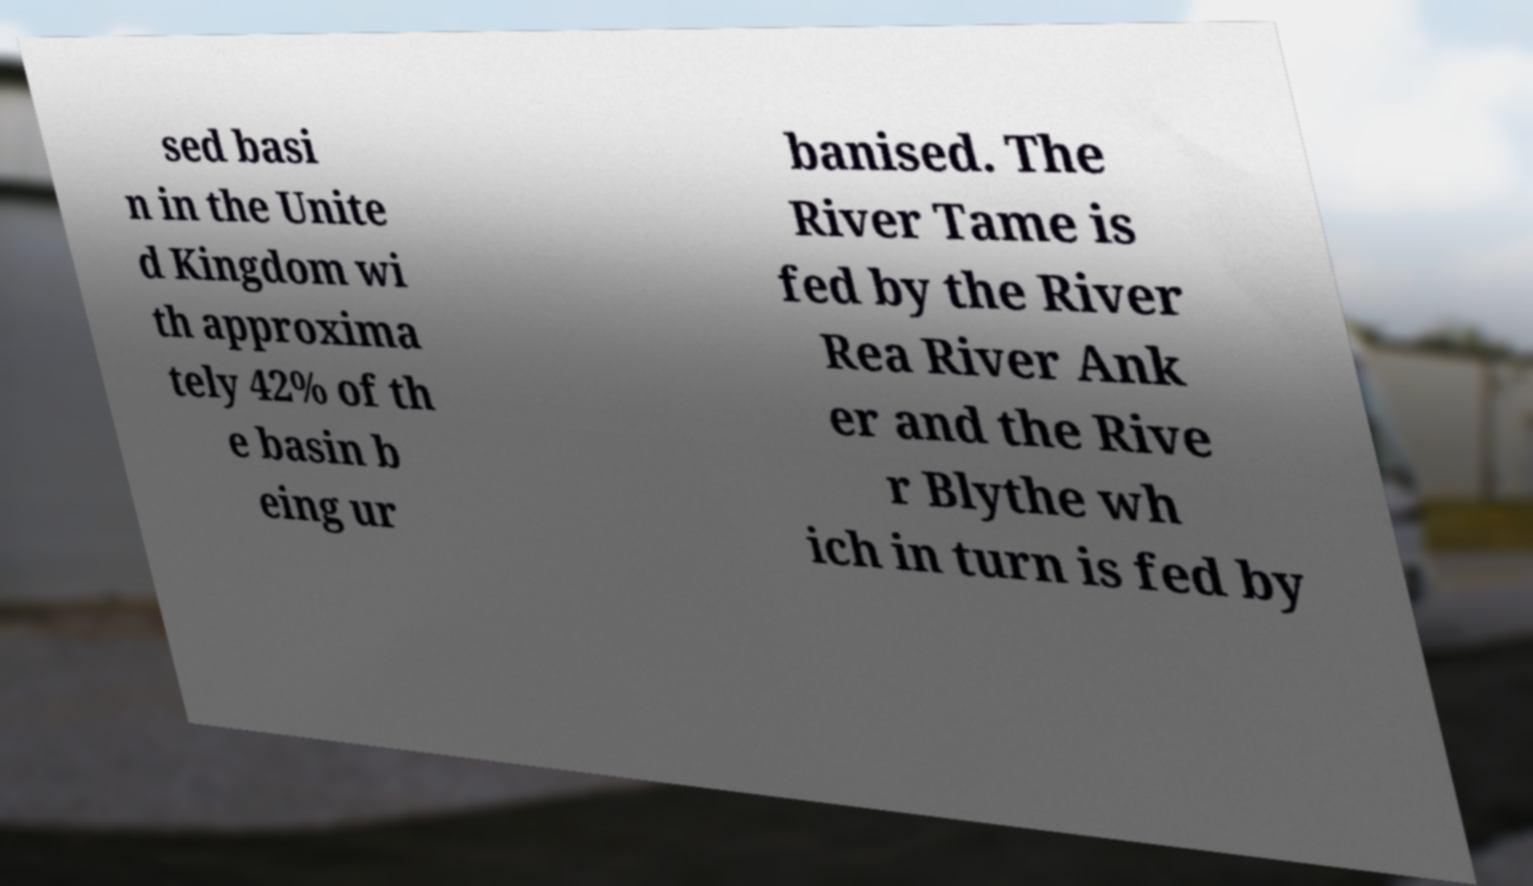Please read and relay the text visible in this image. What does it say? sed basi n in the Unite d Kingdom wi th approxima tely 42% of th e basin b eing ur banised. The River Tame is fed by the River Rea River Ank er and the Rive r Blythe wh ich in turn is fed by 